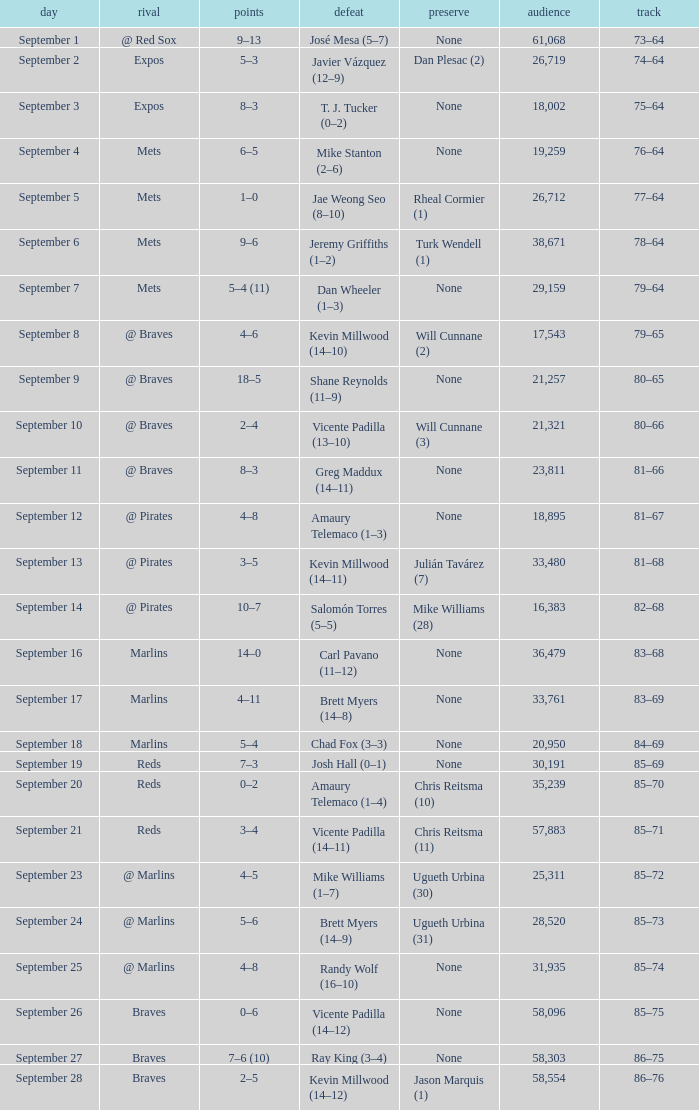What was the score of the game that had a loss of Chad Fox (3–3)? 5–4. 